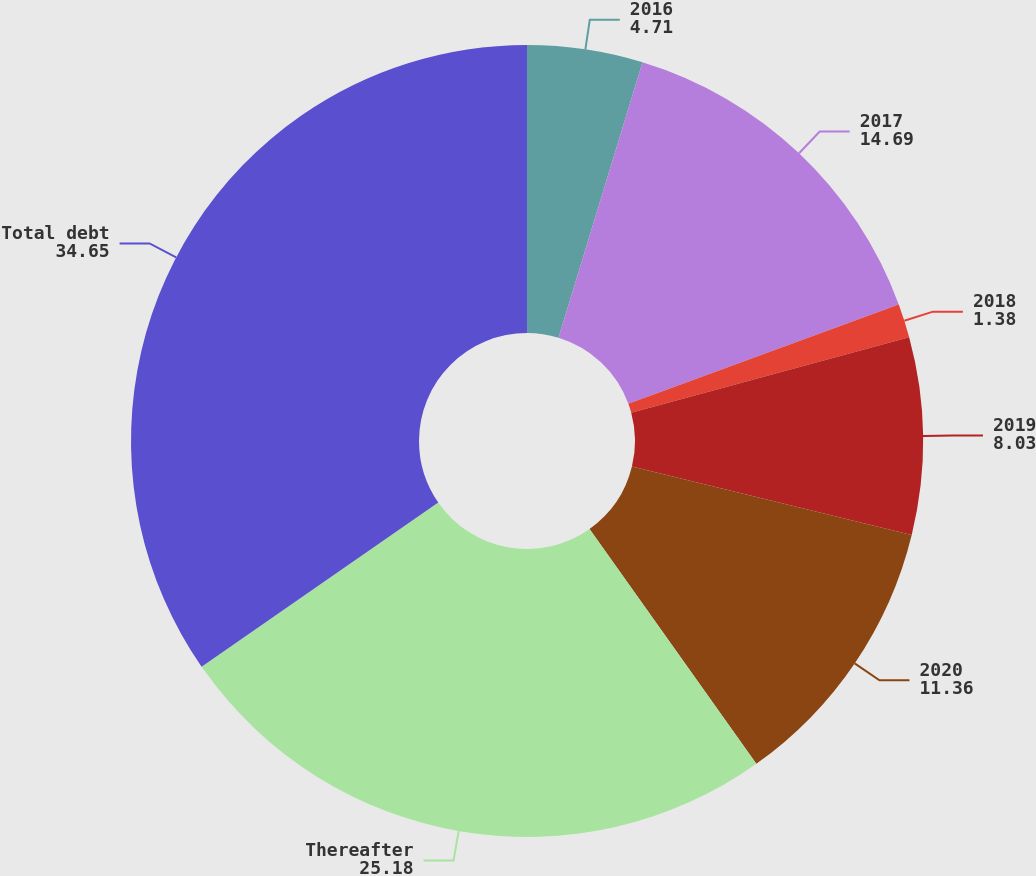<chart> <loc_0><loc_0><loc_500><loc_500><pie_chart><fcel>2016<fcel>2017<fcel>2018<fcel>2019<fcel>2020<fcel>Thereafter<fcel>Total debt<nl><fcel>4.71%<fcel>14.69%<fcel>1.38%<fcel>8.03%<fcel>11.36%<fcel>25.18%<fcel>34.65%<nl></chart> 